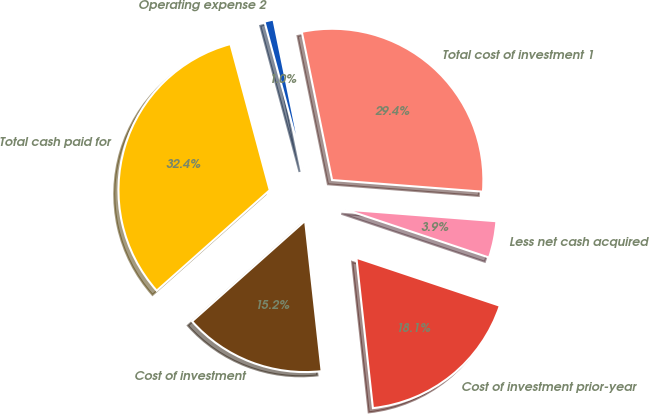Convert chart to OTSL. <chart><loc_0><loc_0><loc_500><loc_500><pie_chart><fcel>Cost of investment<fcel>Cost of investment prior-year<fcel>Less net cash acquired<fcel>Total cost of investment 1<fcel>Operating expense 2<fcel>Total cash paid for<nl><fcel>15.17%<fcel>18.12%<fcel>3.91%<fcel>29.44%<fcel>0.97%<fcel>32.39%<nl></chart> 